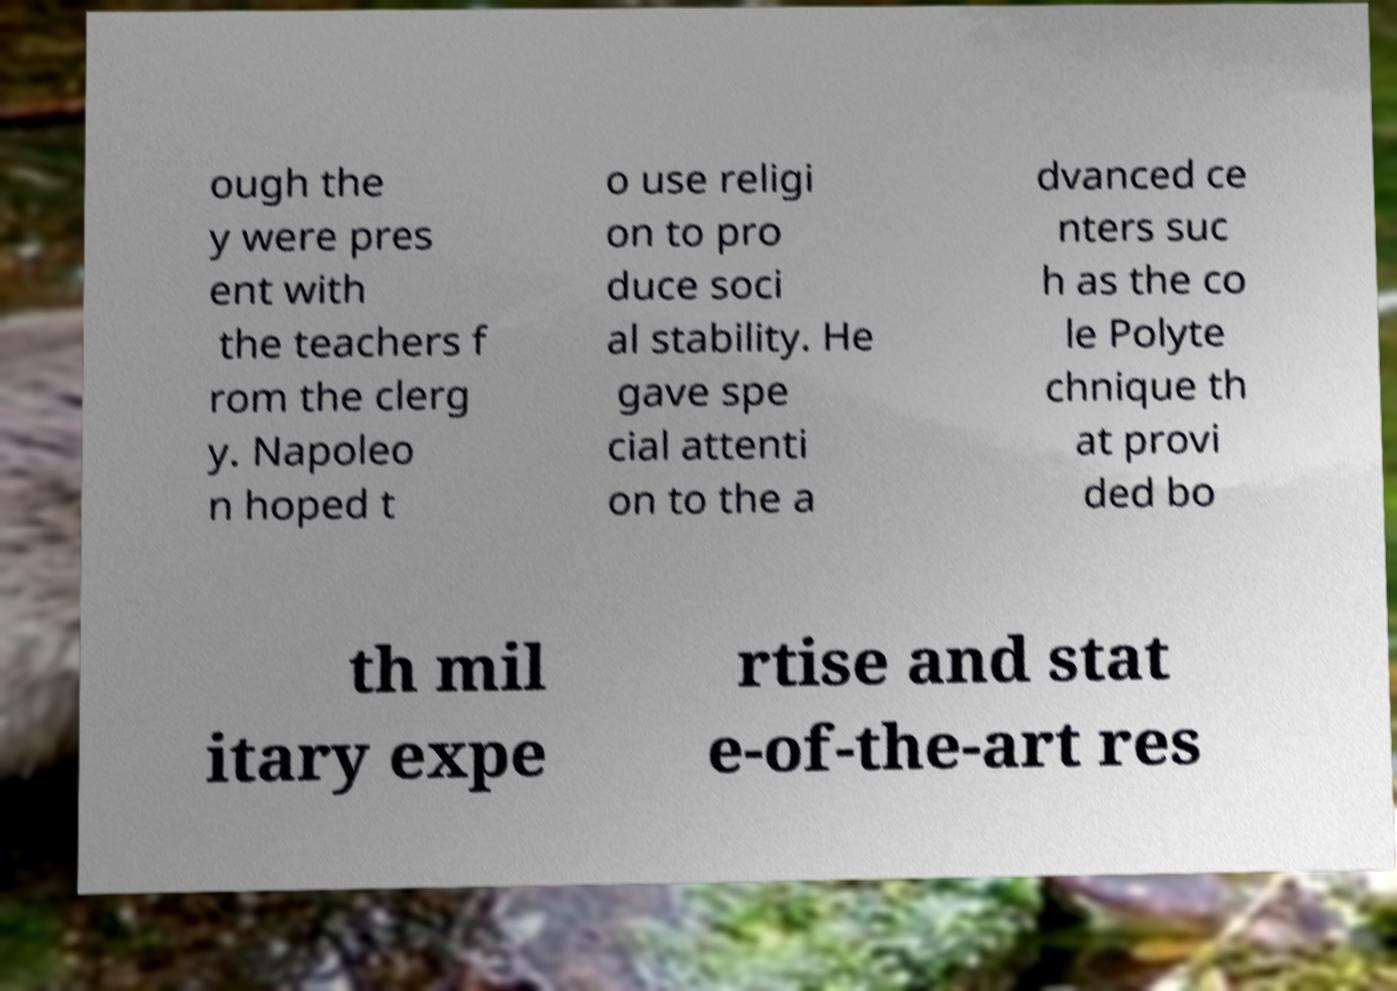For documentation purposes, I need the text within this image transcribed. Could you provide that? ough the y were pres ent with the teachers f rom the clerg y. Napoleo n hoped t o use religi on to pro duce soci al stability. He gave spe cial attenti on to the a dvanced ce nters suc h as the co le Polyte chnique th at provi ded bo th mil itary expe rtise and stat e-of-the-art res 